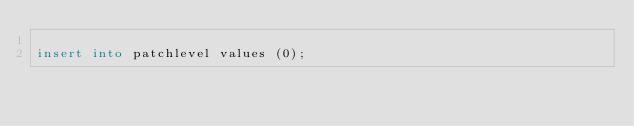<code> <loc_0><loc_0><loc_500><loc_500><_SQL_>
insert into patchlevel values (0);</code> 